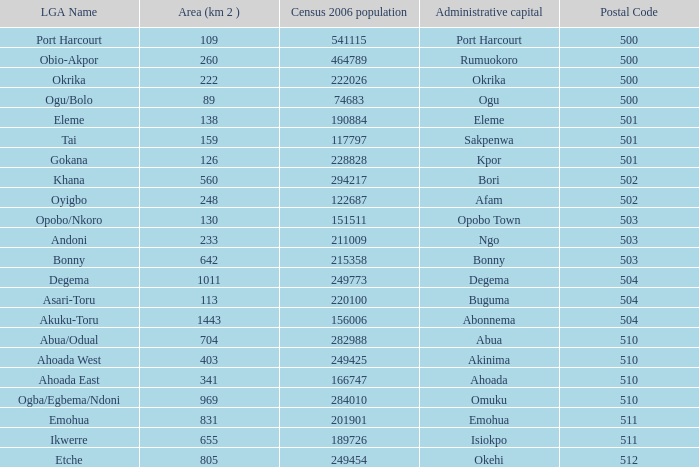What is the zone when the iga name is ahoada east? 341.0. 